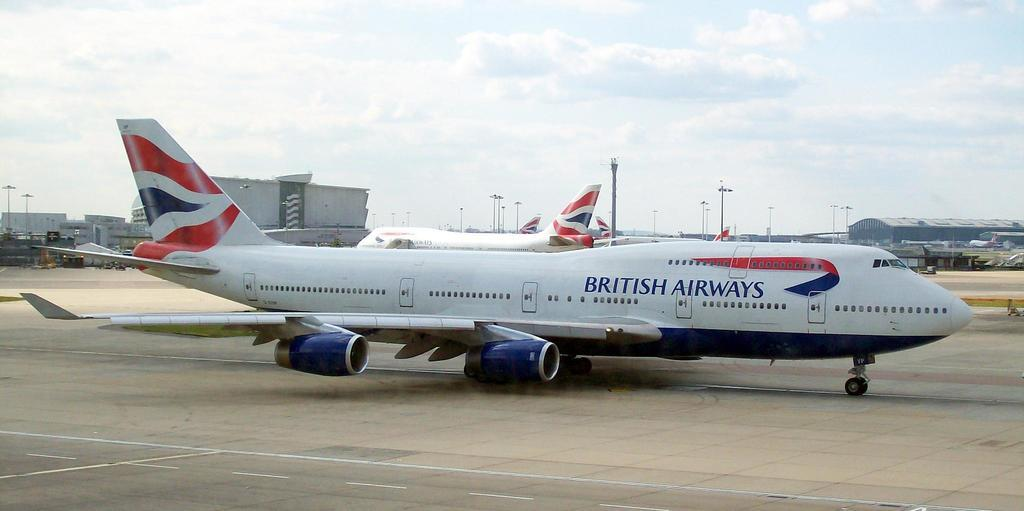Provide a one-sentence caption for the provided image. A British Airways jet is sitting on the tarmac at an airport. 